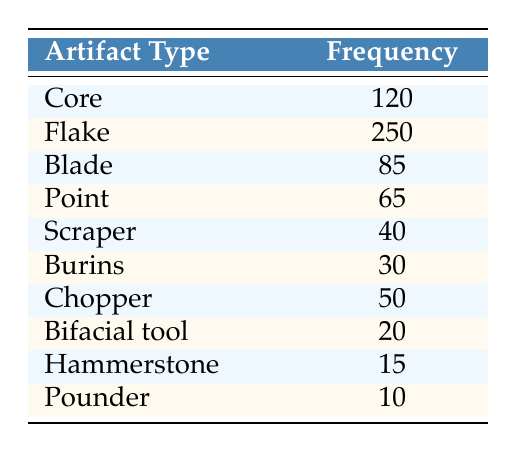What is the frequency of Flake artifacts? The frequency of Flake artifacts is directly listed in the table under the "Frequency" column corresponding to the "Flake" row.
Answer: 250 How many more Core artifacts were found than Chopper artifacts? The frequency of Core artifacts is 120, and the frequency of Chopper artifacts is 50. By subtracting the two values: 120 - 50 = 70.
Answer: 70 What is the total frequency of all types of lithic artifacts listed? To find the total frequency, add the frequencies of all artifact types: 120 + 250 + 85 + 65 + 40 + 30 + 50 + 20 + 15 + 10. The sum is 120 + 250 + 85 + 65 + 40 + 30 + 50 + 20 + 15 + 10 = 675.
Answer: 675 Are there more Scraper artifacts or Burins? The frequency of Scraper artifacts is 40, and the frequency of Burins is 30. Since 40 is greater than 30, the answer is yes.
Answer: Yes What is the average frequency of the lithic artifacts listed? To find the average, sum all frequencies (675) and divide by the number of artifact types (10): 675 / 10 = 67.5.
Answer: 67.5 Which artifact type has the lowest frequency? By scanning through the "Frequency" column, it is evident that the Pounder has the lowest recorded frequency of 10.
Answer: Pounder Is the frequency of Blade artifacts greater than that of Point artifacts? The frequency of Blade artifacts is 85 and the frequency of Point artifacts is 65. Since 85 is greater than 65, the answer is true.
Answer: True How many more Flake artifacts are there than the combined frequency of Point and Burins? The combined frequency of Point (65) and Burins (30) is 95. The frequency of Flake artifacts is 250. So, 250 - 95 = 155.
Answer: 155 